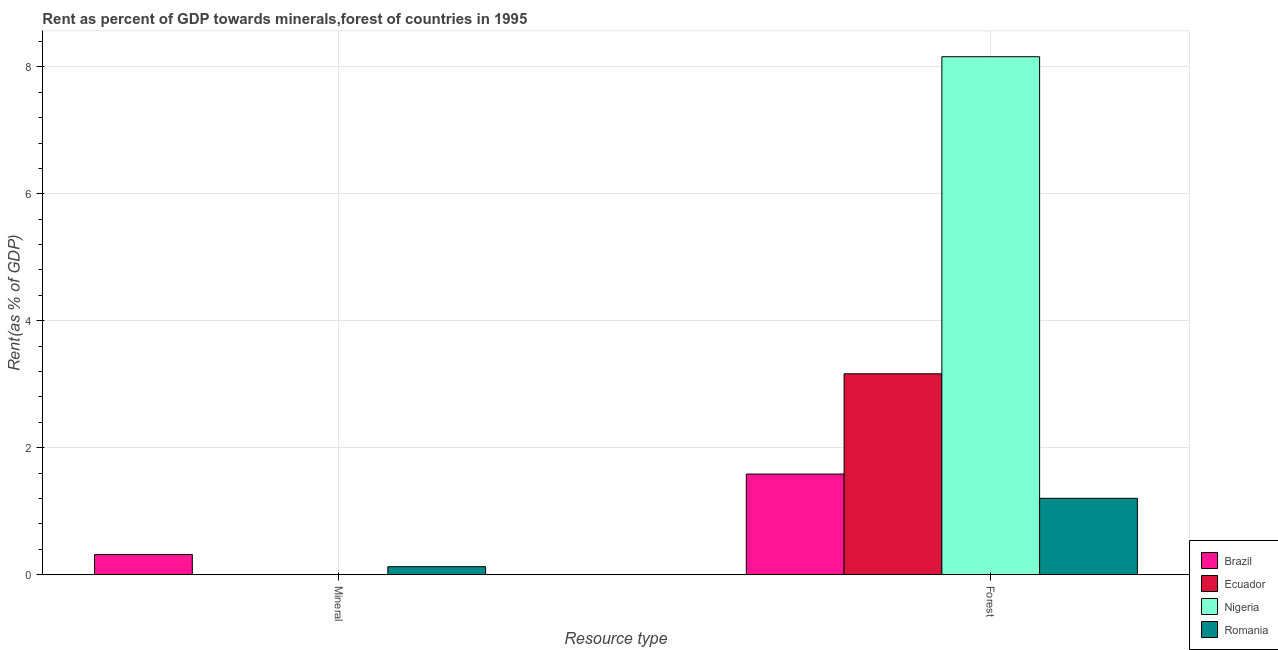How many different coloured bars are there?
Give a very brief answer. 4. Are the number of bars per tick equal to the number of legend labels?
Your response must be concise. Yes. Are the number of bars on each tick of the X-axis equal?
Provide a short and direct response. Yes. What is the label of the 2nd group of bars from the left?
Your answer should be very brief. Forest. What is the forest rent in Brazil?
Your response must be concise. 1.59. Across all countries, what is the maximum mineral rent?
Give a very brief answer. 0.32. Across all countries, what is the minimum mineral rent?
Your response must be concise. 0. In which country was the forest rent maximum?
Your response must be concise. Nigeria. In which country was the forest rent minimum?
Offer a terse response. Romania. What is the total forest rent in the graph?
Give a very brief answer. 14.11. What is the difference between the mineral rent in Nigeria and that in Brazil?
Ensure brevity in your answer.  -0.32. What is the difference between the forest rent in Nigeria and the mineral rent in Brazil?
Provide a short and direct response. 7.84. What is the average forest rent per country?
Your answer should be very brief. 3.53. What is the difference between the forest rent and mineral rent in Romania?
Provide a short and direct response. 1.08. What is the ratio of the mineral rent in Ecuador to that in Brazil?
Give a very brief answer. 0. In how many countries, is the mineral rent greater than the average mineral rent taken over all countries?
Ensure brevity in your answer.  2. What does the 3rd bar from the left in Mineral represents?
Your response must be concise. Nigeria. What does the 2nd bar from the right in Forest represents?
Your response must be concise. Nigeria. How many bars are there?
Offer a terse response. 8. How many countries are there in the graph?
Keep it short and to the point. 4. What is the difference between two consecutive major ticks on the Y-axis?
Give a very brief answer. 2. Does the graph contain any zero values?
Your response must be concise. No. How are the legend labels stacked?
Your response must be concise. Vertical. What is the title of the graph?
Ensure brevity in your answer.  Rent as percent of GDP towards minerals,forest of countries in 1995. Does "Qatar" appear as one of the legend labels in the graph?
Offer a terse response. No. What is the label or title of the X-axis?
Ensure brevity in your answer.  Resource type. What is the label or title of the Y-axis?
Your response must be concise. Rent(as % of GDP). What is the Rent(as % of GDP) in Brazil in Mineral?
Your response must be concise. 0.32. What is the Rent(as % of GDP) in Ecuador in Mineral?
Give a very brief answer. 0. What is the Rent(as % of GDP) in Nigeria in Mineral?
Make the answer very short. 0. What is the Rent(as % of GDP) in Romania in Mineral?
Give a very brief answer. 0.13. What is the Rent(as % of GDP) of Brazil in Forest?
Offer a terse response. 1.59. What is the Rent(as % of GDP) of Ecuador in Forest?
Offer a very short reply. 3.16. What is the Rent(as % of GDP) of Nigeria in Forest?
Your response must be concise. 8.16. What is the Rent(as % of GDP) of Romania in Forest?
Provide a short and direct response. 1.2. Across all Resource type, what is the maximum Rent(as % of GDP) of Brazil?
Your answer should be compact. 1.59. Across all Resource type, what is the maximum Rent(as % of GDP) of Ecuador?
Ensure brevity in your answer.  3.16. Across all Resource type, what is the maximum Rent(as % of GDP) of Nigeria?
Ensure brevity in your answer.  8.16. Across all Resource type, what is the maximum Rent(as % of GDP) in Romania?
Ensure brevity in your answer.  1.2. Across all Resource type, what is the minimum Rent(as % of GDP) in Brazil?
Ensure brevity in your answer.  0.32. Across all Resource type, what is the minimum Rent(as % of GDP) in Ecuador?
Give a very brief answer. 0. Across all Resource type, what is the minimum Rent(as % of GDP) of Nigeria?
Keep it short and to the point. 0. Across all Resource type, what is the minimum Rent(as % of GDP) of Romania?
Your answer should be compact. 0.13. What is the total Rent(as % of GDP) of Brazil in the graph?
Your response must be concise. 1.9. What is the total Rent(as % of GDP) of Ecuador in the graph?
Ensure brevity in your answer.  3.16. What is the total Rent(as % of GDP) of Nigeria in the graph?
Your response must be concise. 8.16. What is the total Rent(as % of GDP) in Romania in the graph?
Ensure brevity in your answer.  1.33. What is the difference between the Rent(as % of GDP) in Brazil in Mineral and that in Forest?
Provide a short and direct response. -1.27. What is the difference between the Rent(as % of GDP) in Ecuador in Mineral and that in Forest?
Your answer should be very brief. -3.16. What is the difference between the Rent(as % of GDP) in Nigeria in Mineral and that in Forest?
Ensure brevity in your answer.  -8.16. What is the difference between the Rent(as % of GDP) in Romania in Mineral and that in Forest?
Provide a short and direct response. -1.08. What is the difference between the Rent(as % of GDP) of Brazil in Mineral and the Rent(as % of GDP) of Ecuador in Forest?
Keep it short and to the point. -2.85. What is the difference between the Rent(as % of GDP) in Brazil in Mineral and the Rent(as % of GDP) in Nigeria in Forest?
Make the answer very short. -7.84. What is the difference between the Rent(as % of GDP) of Brazil in Mineral and the Rent(as % of GDP) of Romania in Forest?
Offer a very short reply. -0.89. What is the difference between the Rent(as % of GDP) in Ecuador in Mineral and the Rent(as % of GDP) in Nigeria in Forest?
Your answer should be compact. -8.16. What is the difference between the Rent(as % of GDP) in Ecuador in Mineral and the Rent(as % of GDP) in Romania in Forest?
Make the answer very short. -1.2. What is the difference between the Rent(as % of GDP) in Nigeria in Mineral and the Rent(as % of GDP) in Romania in Forest?
Ensure brevity in your answer.  -1.2. What is the average Rent(as % of GDP) in Brazil per Resource type?
Give a very brief answer. 0.95. What is the average Rent(as % of GDP) in Ecuador per Resource type?
Give a very brief answer. 1.58. What is the average Rent(as % of GDP) in Nigeria per Resource type?
Provide a succinct answer. 4.08. What is the average Rent(as % of GDP) in Romania per Resource type?
Offer a terse response. 0.66. What is the difference between the Rent(as % of GDP) of Brazil and Rent(as % of GDP) of Ecuador in Mineral?
Make the answer very short. 0.32. What is the difference between the Rent(as % of GDP) of Brazil and Rent(as % of GDP) of Nigeria in Mineral?
Offer a terse response. 0.32. What is the difference between the Rent(as % of GDP) of Brazil and Rent(as % of GDP) of Romania in Mineral?
Keep it short and to the point. 0.19. What is the difference between the Rent(as % of GDP) in Ecuador and Rent(as % of GDP) in Nigeria in Mineral?
Provide a succinct answer. -0. What is the difference between the Rent(as % of GDP) of Ecuador and Rent(as % of GDP) of Romania in Mineral?
Keep it short and to the point. -0.13. What is the difference between the Rent(as % of GDP) of Nigeria and Rent(as % of GDP) of Romania in Mineral?
Your answer should be very brief. -0.12. What is the difference between the Rent(as % of GDP) in Brazil and Rent(as % of GDP) in Ecuador in Forest?
Provide a succinct answer. -1.58. What is the difference between the Rent(as % of GDP) in Brazil and Rent(as % of GDP) in Nigeria in Forest?
Provide a succinct answer. -6.57. What is the difference between the Rent(as % of GDP) in Brazil and Rent(as % of GDP) in Romania in Forest?
Your answer should be very brief. 0.38. What is the difference between the Rent(as % of GDP) of Ecuador and Rent(as % of GDP) of Nigeria in Forest?
Your answer should be compact. -4.99. What is the difference between the Rent(as % of GDP) of Ecuador and Rent(as % of GDP) of Romania in Forest?
Offer a very short reply. 1.96. What is the difference between the Rent(as % of GDP) of Nigeria and Rent(as % of GDP) of Romania in Forest?
Ensure brevity in your answer.  6.96. What is the ratio of the Rent(as % of GDP) in Brazil in Mineral to that in Forest?
Your answer should be compact. 0.2. What is the ratio of the Rent(as % of GDP) of Romania in Mineral to that in Forest?
Keep it short and to the point. 0.1. What is the difference between the highest and the second highest Rent(as % of GDP) of Brazil?
Offer a terse response. 1.27. What is the difference between the highest and the second highest Rent(as % of GDP) in Ecuador?
Offer a very short reply. 3.16. What is the difference between the highest and the second highest Rent(as % of GDP) in Nigeria?
Ensure brevity in your answer.  8.16. What is the difference between the highest and the second highest Rent(as % of GDP) of Romania?
Give a very brief answer. 1.08. What is the difference between the highest and the lowest Rent(as % of GDP) of Brazil?
Your response must be concise. 1.27. What is the difference between the highest and the lowest Rent(as % of GDP) of Ecuador?
Provide a succinct answer. 3.16. What is the difference between the highest and the lowest Rent(as % of GDP) in Nigeria?
Ensure brevity in your answer.  8.16. What is the difference between the highest and the lowest Rent(as % of GDP) of Romania?
Your answer should be compact. 1.08. 